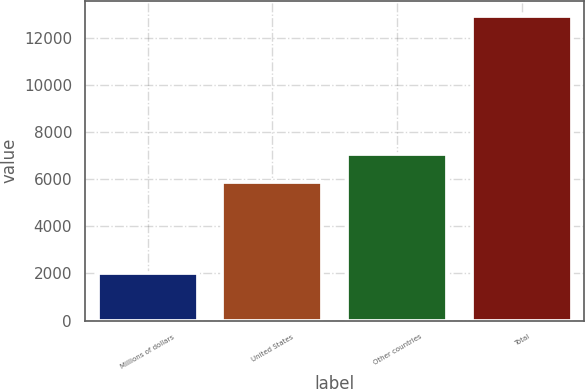Convert chart. <chart><loc_0><loc_0><loc_500><loc_500><bar_chart><fcel>Millions of dollars<fcel>United States<fcel>Other countries<fcel>Total<nl><fcel>2006<fcel>5869<fcel>7086<fcel>12955<nl></chart> 